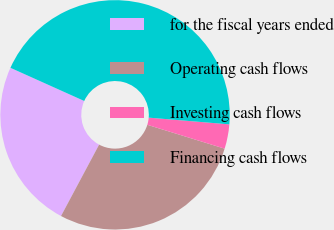Convert chart. <chart><loc_0><loc_0><loc_500><loc_500><pie_chart><fcel>for the fiscal years ended<fcel>Operating cash flows<fcel>Investing cash flows<fcel>Financing cash flows<nl><fcel>23.92%<fcel>28.04%<fcel>3.44%<fcel>44.6%<nl></chart> 